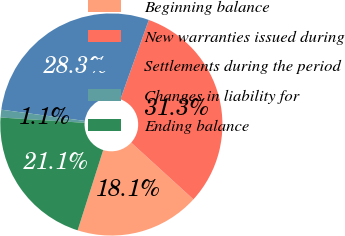Convert chart. <chart><loc_0><loc_0><loc_500><loc_500><pie_chart><fcel>Beginning balance<fcel>New warranties issued during<fcel>Settlements during the period<fcel>Changes in liability for<fcel>Ending balance<nl><fcel>18.14%<fcel>31.29%<fcel>28.34%<fcel>1.13%<fcel>21.09%<nl></chart> 